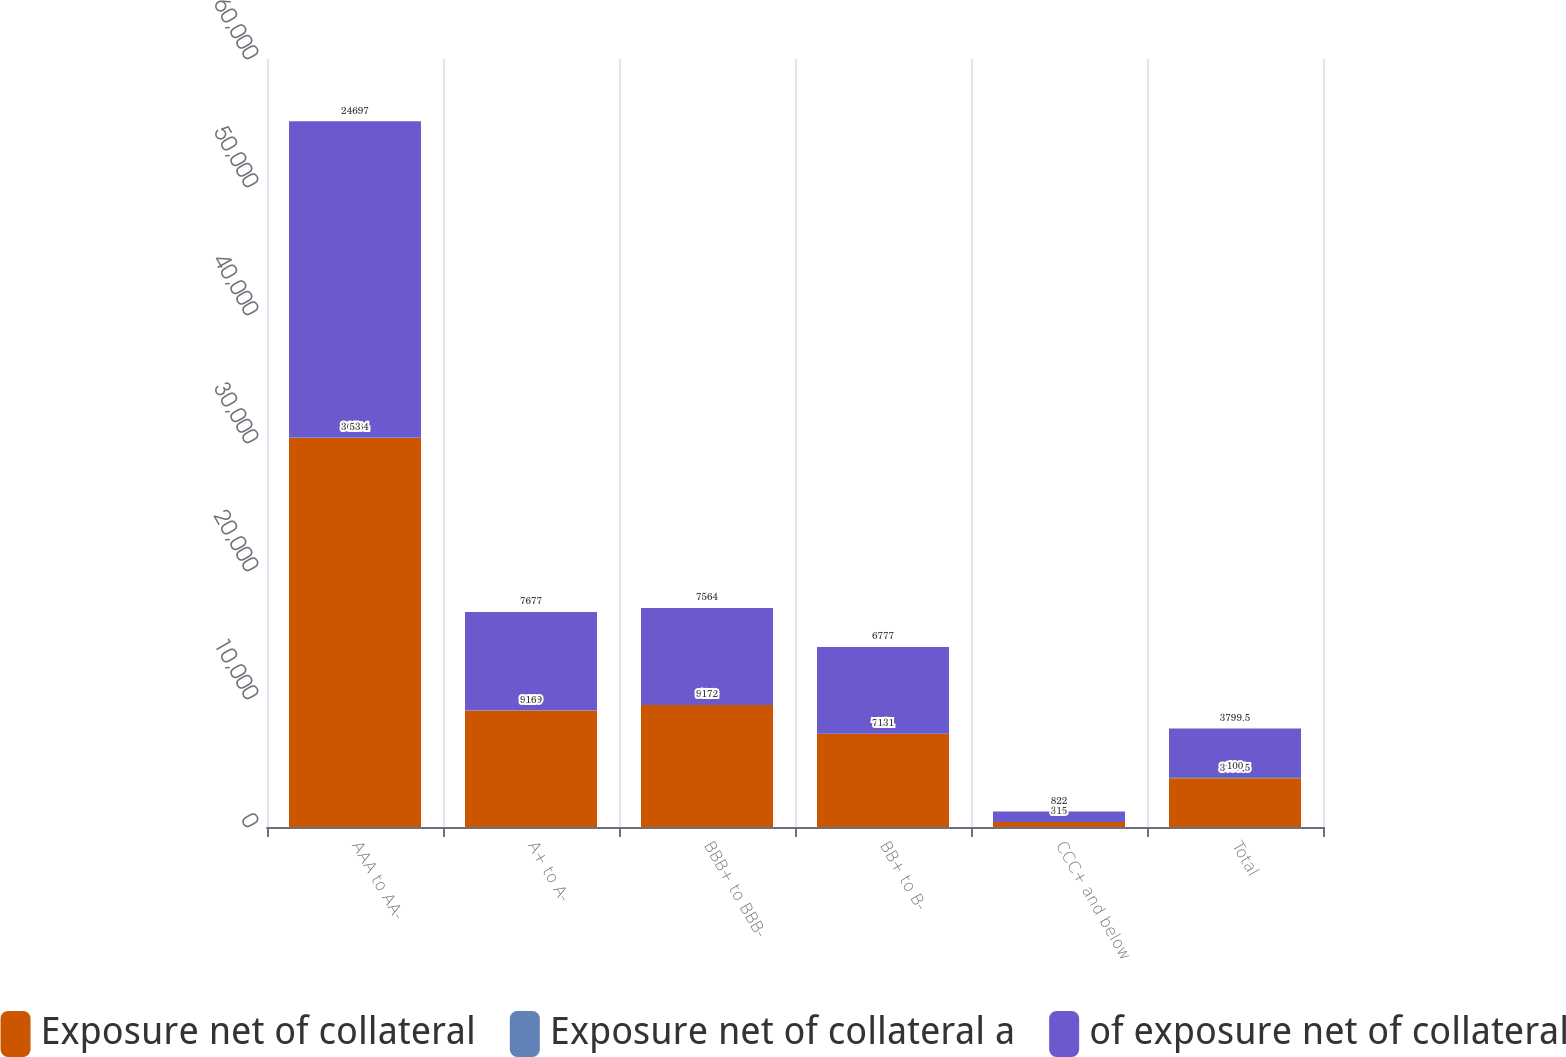<chart> <loc_0><loc_0><loc_500><loc_500><stacked_bar_chart><ecel><fcel>AAA to AA-<fcel>A+ to A-<fcel>BBB+ to BBB-<fcel>BB+ to B-<fcel>CCC+ and below<fcel>Total<nl><fcel>Exposure net of collateral<fcel>30384<fcel>9109<fcel>9522<fcel>7271<fcel>395<fcel>3799.5<nl><fcel>Exposure net of collateral a<fcel>53<fcel>16<fcel>17<fcel>13<fcel>1<fcel>100<nl><fcel>of exposure net of collateral<fcel>24697<fcel>7677<fcel>7564<fcel>6777<fcel>822<fcel>3799.5<nl></chart> 